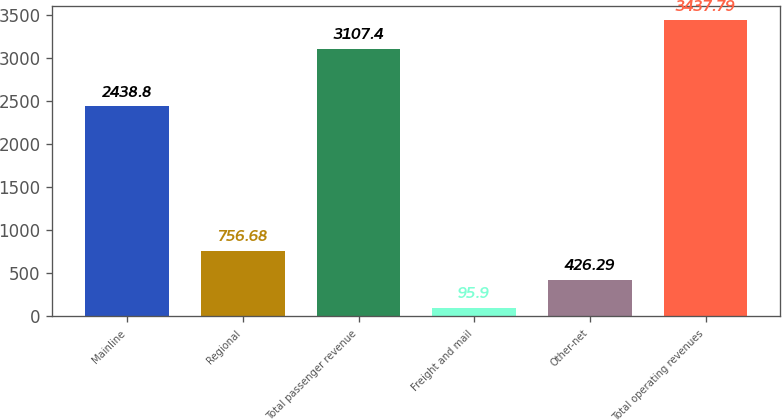Convert chart. <chart><loc_0><loc_0><loc_500><loc_500><bar_chart><fcel>Mainline<fcel>Regional<fcel>Total passenger revenue<fcel>Freight and mail<fcel>Other-net<fcel>Total operating revenues<nl><fcel>2438.8<fcel>756.68<fcel>3107.4<fcel>95.9<fcel>426.29<fcel>3437.79<nl></chart> 